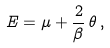<formula> <loc_0><loc_0><loc_500><loc_500>E = \mu + \frac { 2 } { \beta } \, \theta \, ,</formula> 